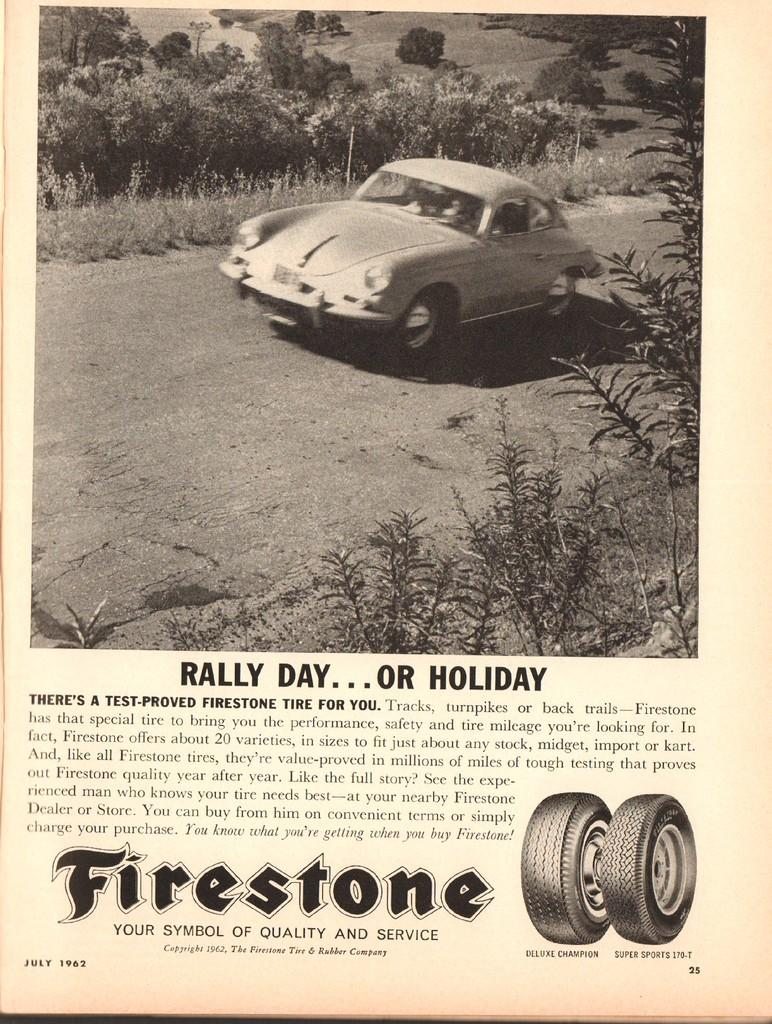What type of image is being described? The image is a poster. What is the main subject of the poster? There is a picture of a car on the road. What other elements can be seen in the image? There are trees and plants in the image. Are there any words or letters on the poster? Yes, there are letters on the image. How many wheels does the car have? The car has two wheels. What color is the bit of food on the car's dashboard? There is no bit of food present on the car's dashboard in the image. 